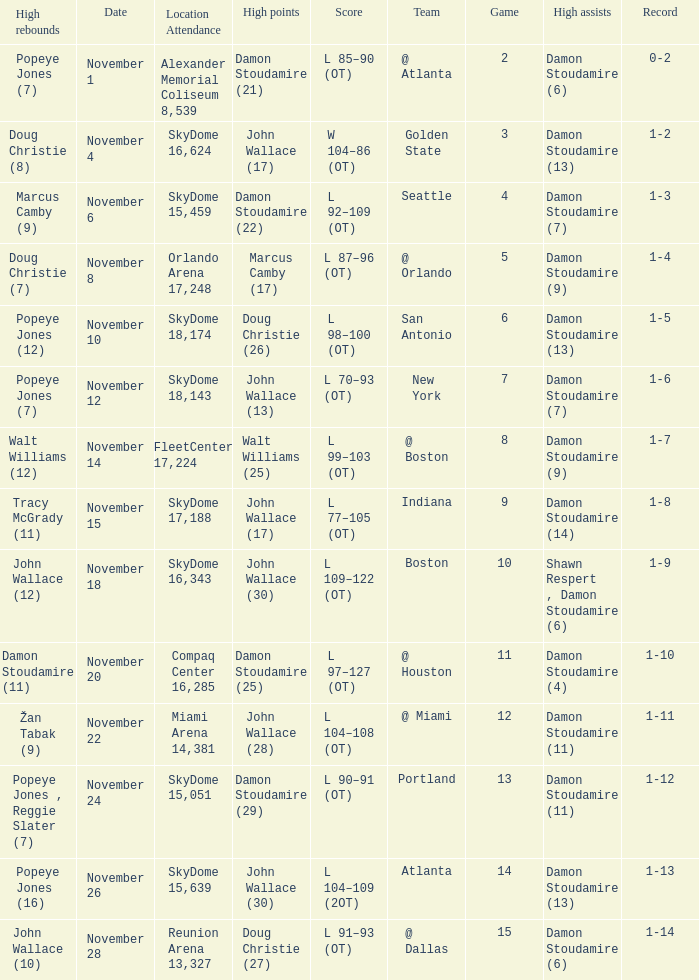How many games did the team play when they were 1-3? 1.0. 